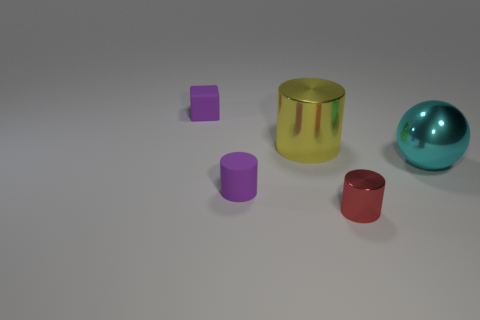Add 1 cyan metal objects. How many objects exist? 6 Subtract all cylinders. How many objects are left? 2 Add 5 cyan metallic things. How many cyan metallic things are left? 6 Add 5 big metal balls. How many big metal balls exist? 6 Subtract 0 blue cylinders. How many objects are left? 5 Subtract all big cyan metallic objects. Subtract all big things. How many objects are left? 2 